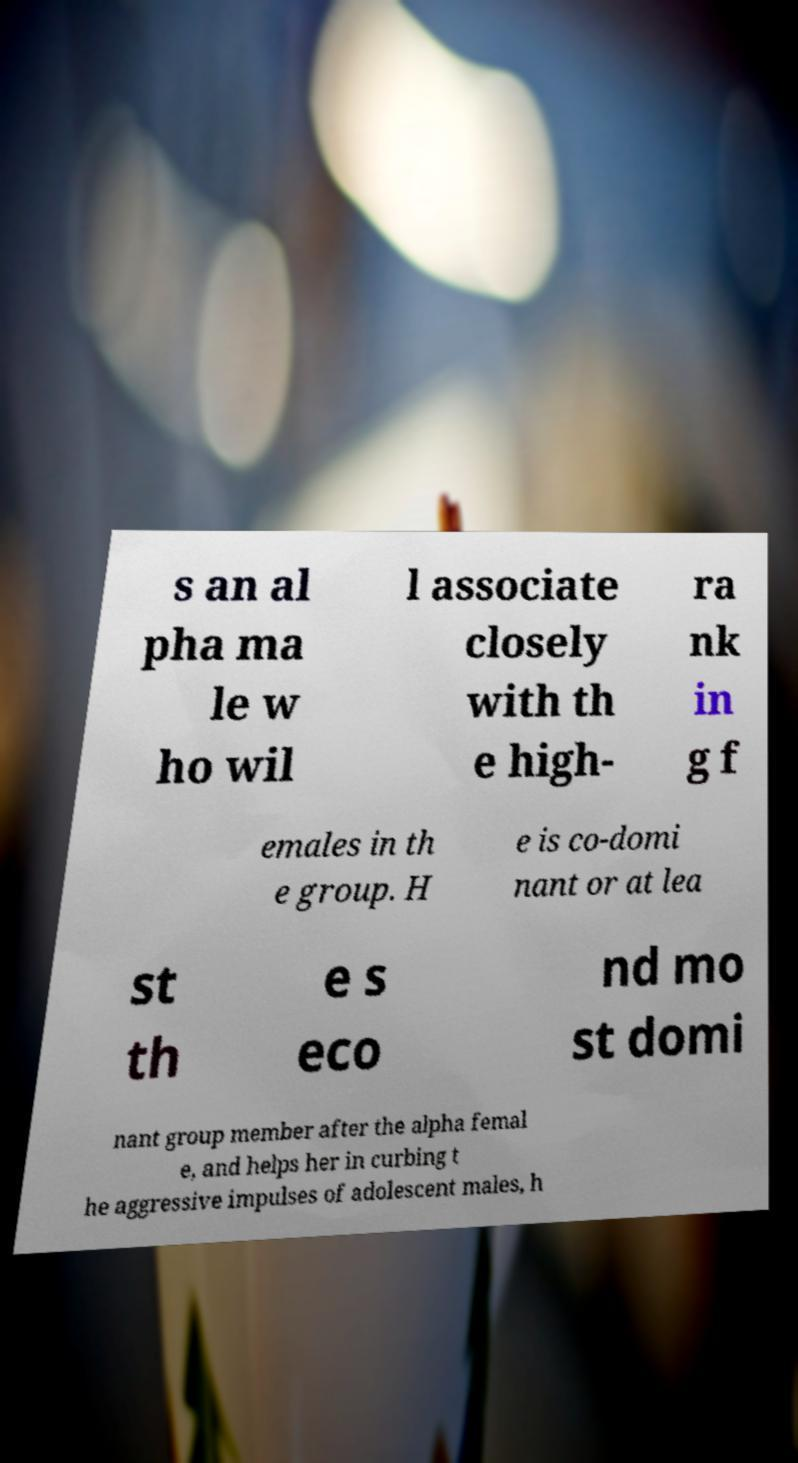What messages or text are displayed in this image? I need them in a readable, typed format. s an al pha ma le w ho wil l associate closely with th e high- ra nk in g f emales in th e group. H e is co-domi nant or at lea st th e s eco nd mo st domi nant group member after the alpha femal e, and helps her in curbing t he aggressive impulses of adolescent males, h 